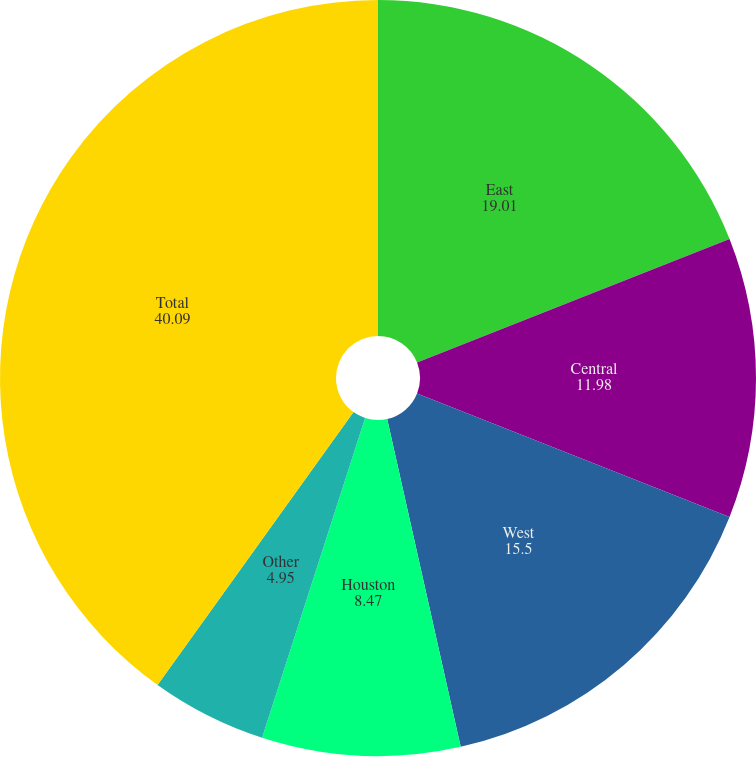Convert chart. <chart><loc_0><loc_0><loc_500><loc_500><pie_chart><fcel>East<fcel>Central<fcel>West<fcel>Houston<fcel>Other<fcel>Total<nl><fcel>19.01%<fcel>11.98%<fcel>15.5%<fcel>8.47%<fcel>4.95%<fcel>40.09%<nl></chart> 